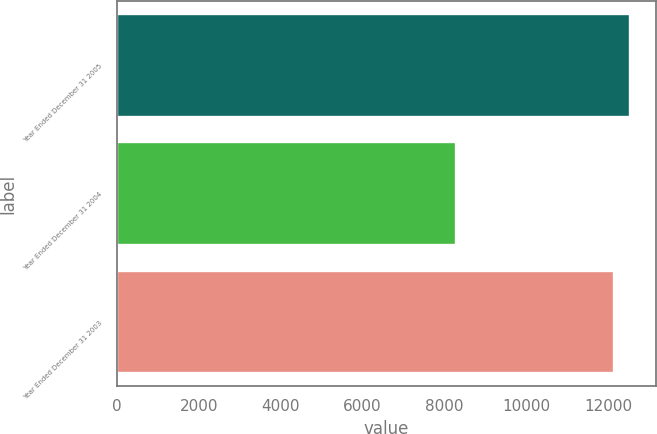Convert chart to OTSL. <chart><loc_0><loc_0><loc_500><loc_500><bar_chart><fcel>Year Ended December 31 2005<fcel>Year Ended December 31 2004<fcel>Year Ended December 31 2003<nl><fcel>12530.4<fcel>8292<fcel>12143<nl></chart> 